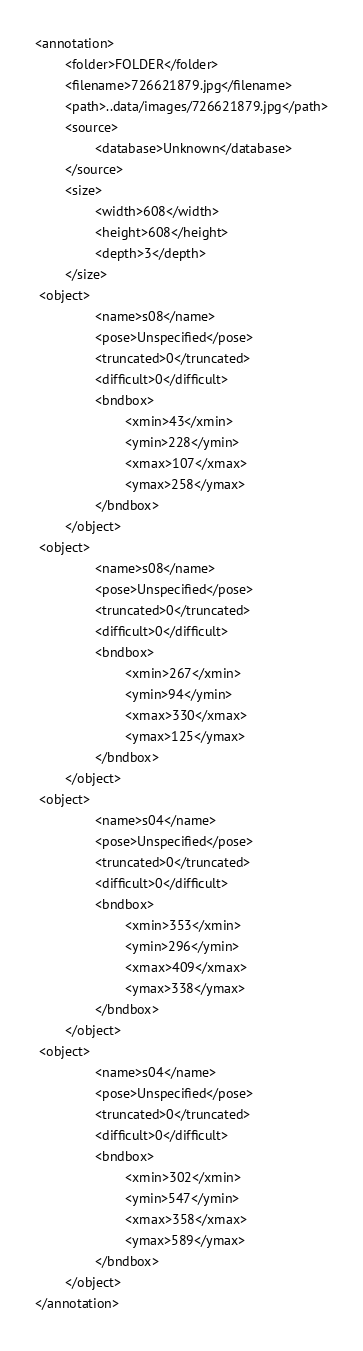Convert code to text. <code><loc_0><loc_0><loc_500><loc_500><_XML_><annotation>
        <folder>FOLDER</folder>
        <filename>726621879.jpg</filename>
        <path>..data/images/726621879.jpg</path>
        <source>
                <database>Unknown</database>
        </source>
        <size>
                <width>608</width>
                <height>608</height>
                <depth>3</depth>
        </size>
 <object>
                <name>s08</name>
                <pose>Unspecified</pose>
                <truncated>0</truncated>
                <difficult>0</difficult>
                <bndbox>
                        <xmin>43</xmin>
                        <ymin>228</ymin>
                        <xmax>107</xmax>
                        <ymax>258</ymax>
                </bndbox>
        </object>
 <object>
                <name>s08</name>
                <pose>Unspecified</pose>
                <truncated>0</truncated>
                <difficult>0</difficult>
                <bndbox>
                        <xmin>267</xmin>
                        <ymin>94</ymin>
                        <xmax>330</xmax>
                        <ymax>125</ymax>
                </bndbox>
        </object>
 <object>
                <name>s04</name>
                <pose>Unspecified</pose>
                <truncated>0</truncated>
                <difficult>0</difficult>
                <bndbox>
                        <xmin>353</xmin>
                        <ymin>296</ymin>
                        <xmax>409</xmax>
                        <ymax>338</ymax>
                </bndbox>
        </object>
 <object>
                <name>s04</name>
                <pose>Unspecified</pose>
                <truncated>0</truncated>
                <difficult>0</difficult>
                <bndbox>
                        <xmin>302</xmin>
                        <ymin>547</ymin>
                        <xmax>358</xmax>
                        <ymax>589</ymax>
                </bndbox>
        </object>
</annotation>
</code> 